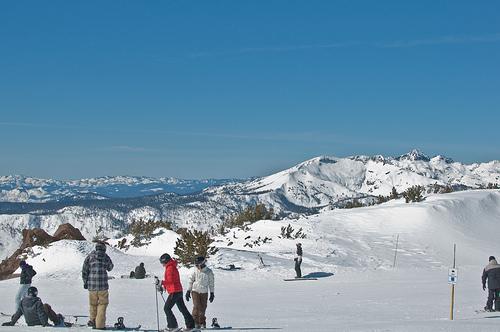Are there people skiing in this picture?
Concise answer only. Yes. What type of skiing is taking place in the image?
Concise answer only. Downhill. Is there a red coat in this picture?
Short answer required. Yes. Is it cold?
Concise answer only. Yes. Why is the person on the right, in the blue jacket and using a snowboard, laying down on the snow?
Keep it brief. Not there. 